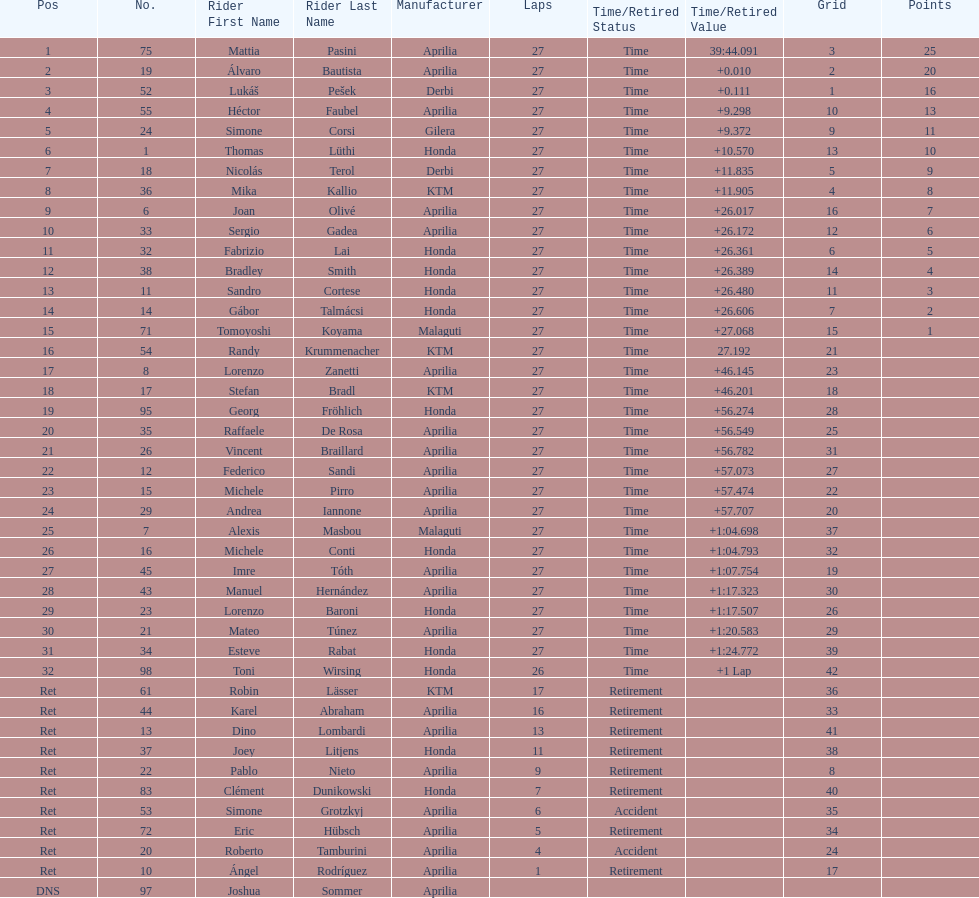What was the total number of positions in the 125cc classification? 43. 